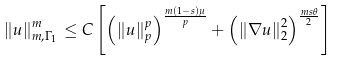<formula> <loc_0><loc_0><loc_500><loc_500>\left \| u \right \| _ { m , \Gamma _ { 1 } } ^ { m } \leq C \left [ \left ( \left \| u \right \| _ { p } ^ { p } \right ) ^ { \frac { m \left ( 1 - s \right ) \mu } { p } } + \left ( \left \| \nabla u \right \| _ { 2 } ^ { 2 } \right ) ^ { \frac { m s \theta } { 2 } } \right ]</formula> 